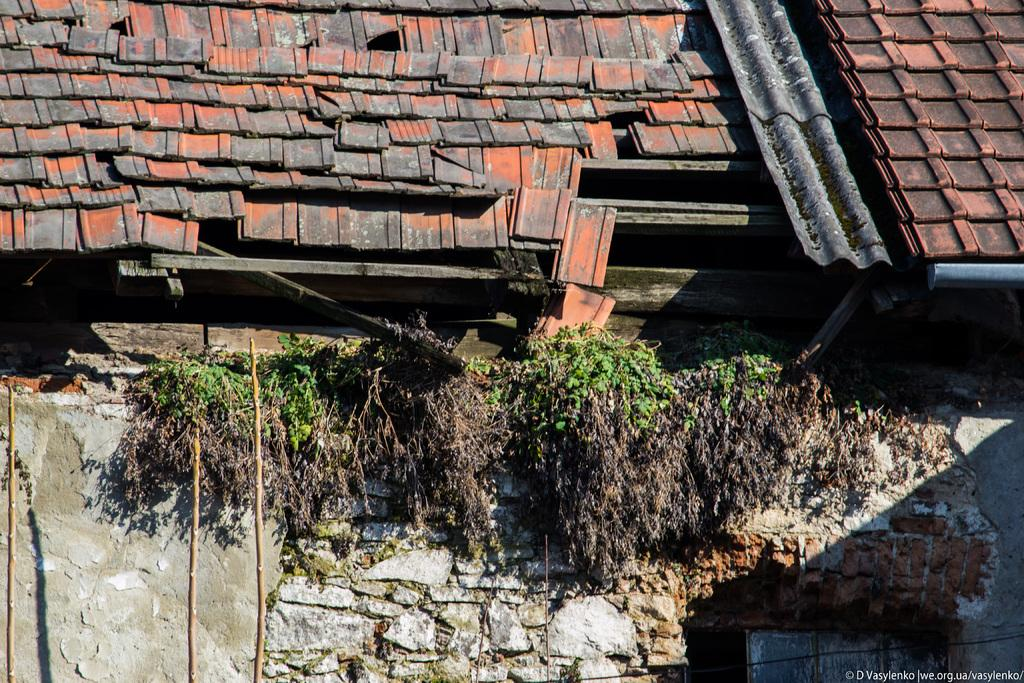What is the main subject of the image? The main subject of the image is the abandoned roof of a building. Are there any other objects or features visible in the image? Yes, there are dry plants on the wall in the image. What type of leather is being used to hold the attention of the vessel in the image? There is no leather, vessel, or attention-holding object present in the image. 